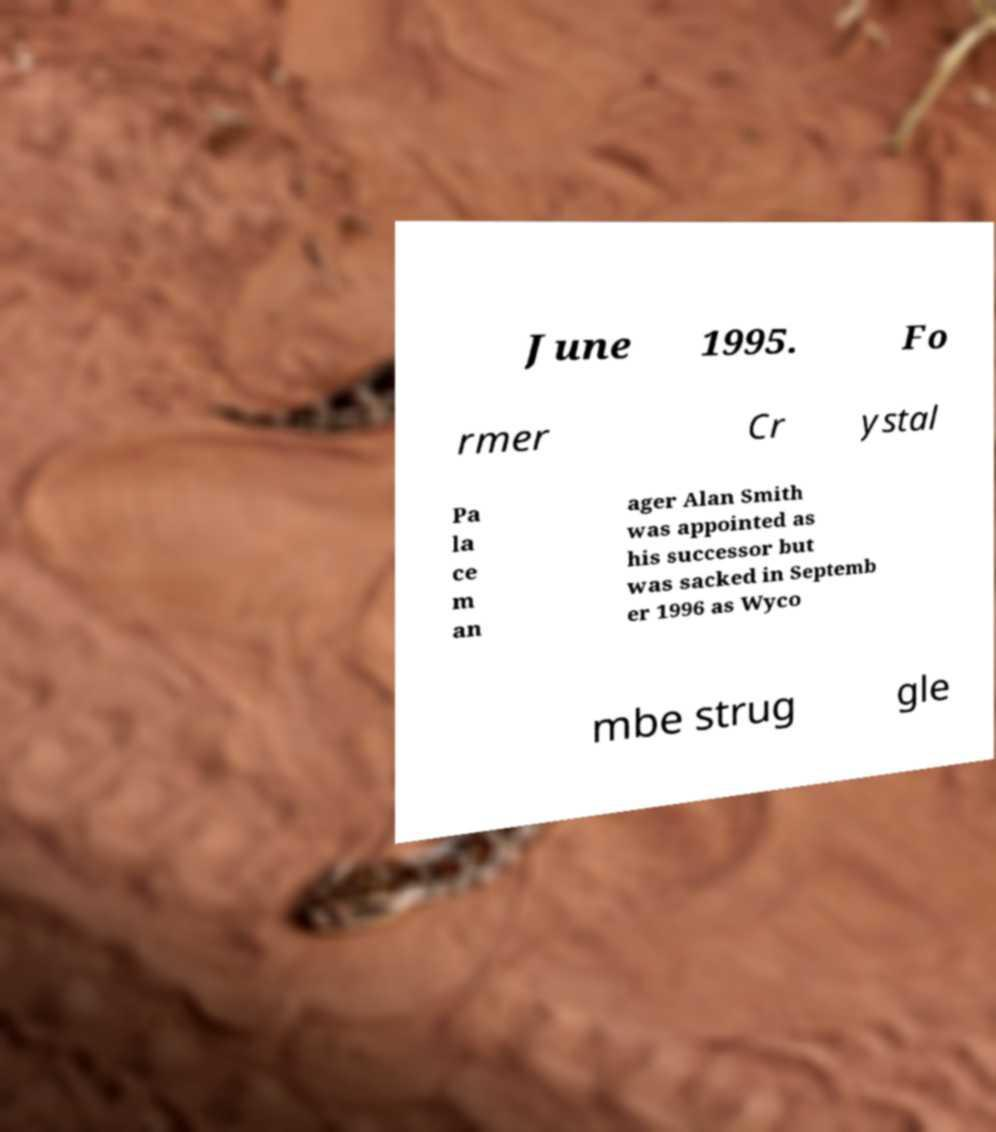I need the written content from this picture converted into text. Can you do that? June 1995. Fo rmer Cr ystal Pa la ce m an ager Alan Smith was appointed as his successor but was sacked in Septemb er 1996 as Wyco mbe strug gle 